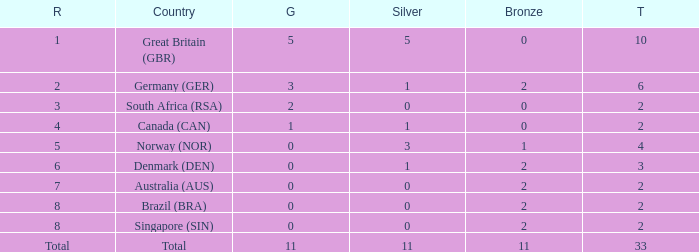What is bronze when the rank is 3 and the total is more than 2? None. 